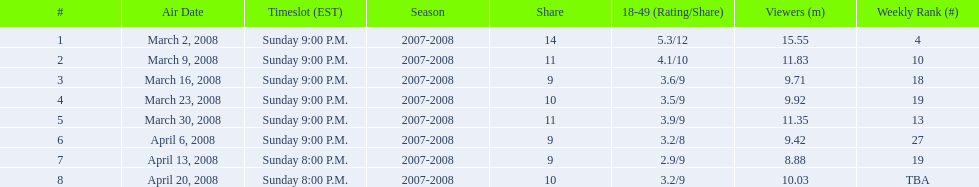During which time slot were the first 6 episodes of the show aired? Sunday 9:00 P.M. 